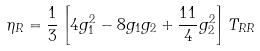<formula> <loc_0><loc_0><loc_500><loc_500>\eta _ { R } = \frac { 1 } { 3 } \left [ 4 g _ { 1 } ^ { 2 } - 8 g _ { 1 } g _ { 2 } + \frac { 1 1 } { 4 } g _ { 2 } ^ { 2 } \right ] T _ { R R }</formula> 